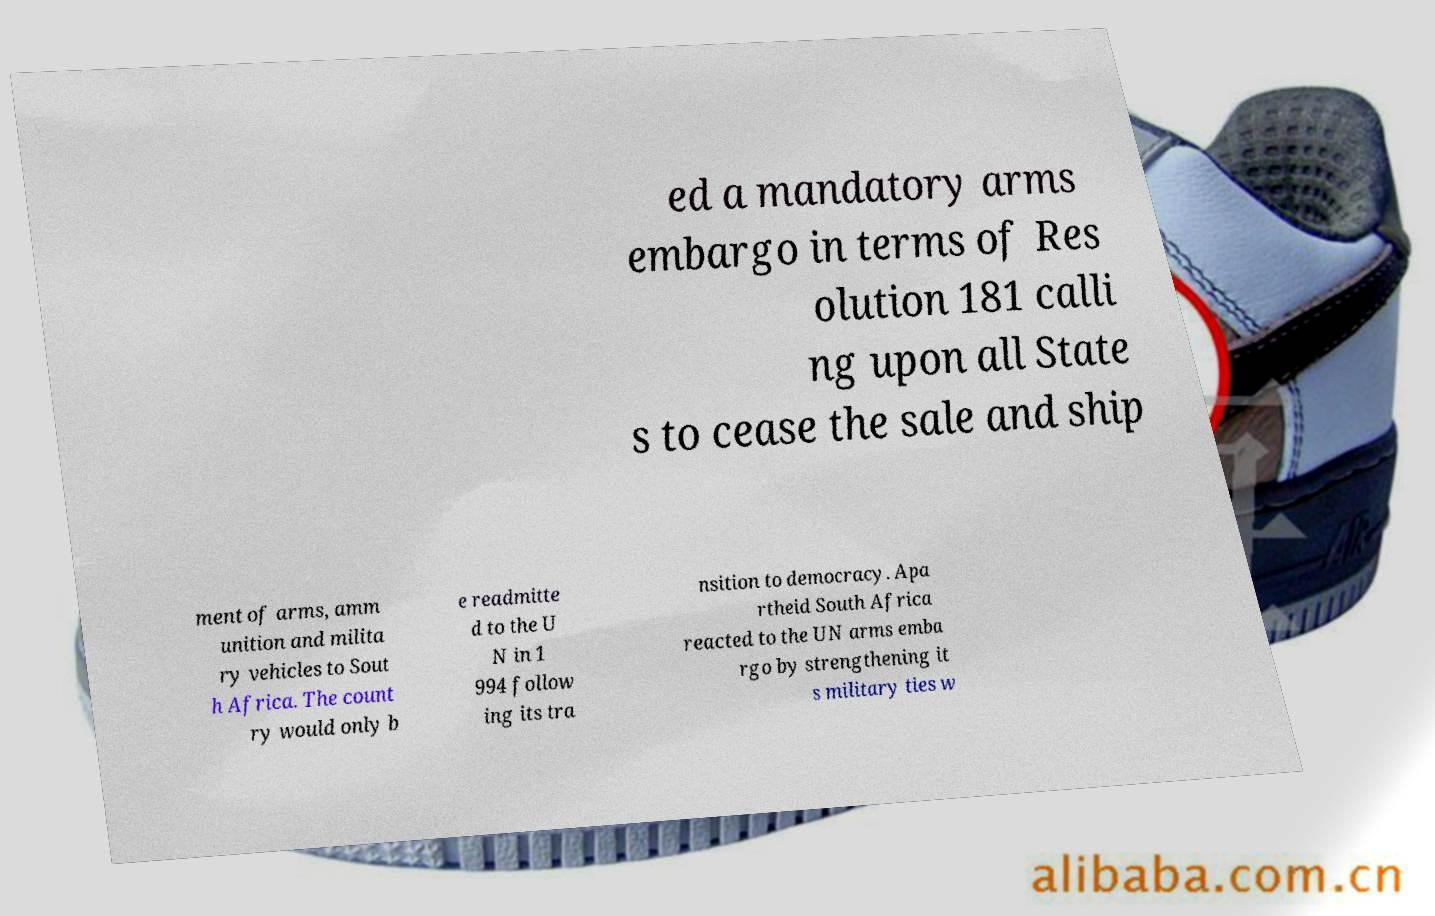I need the written content from this picture converted into text. Can you do that? ed a mandatory arms embargo in terms of Res olution 181 calli ng upon all State s to cease the sale and ship ment of arms, amm unition and milita ry vehicles to Sout h Africa. The count ry would only b e readmitte d to the U N in 1 994 follow ing its tra nsition to democracy. Apa rtheid South Africa reacted to the UN arms emba rgo by strengthening it s military ties w 